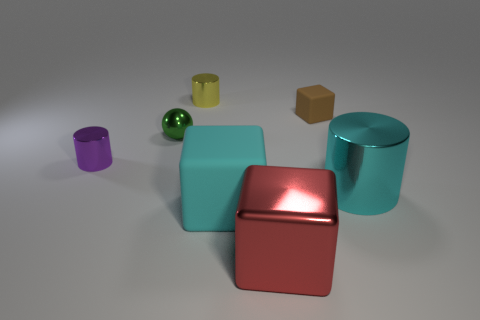Add 1 blocks. How many objects exist? 8 Subtract all big cubes. How many cubes are left? 1 Subtract all cubes. How many objects are left? 4 Subtract all purple cylinders. How many brown cubes are left? 1 Subtract all cyan shiny cylinders. Subtract all shiny spheres. How many objects are left? 5 Add 2 yellow metal cylinders. How many yellow metal cylinders are left? 3 Add 4 big cubes. How many big cubes exist? 6 Subtract 0 blue cylinders. How many objects are left? 7 Subtract 2 cylinders. How many cylinders are left? 1 Subtract all purple spheres. Subtract all green cylinders. How many spheres are left? 1 